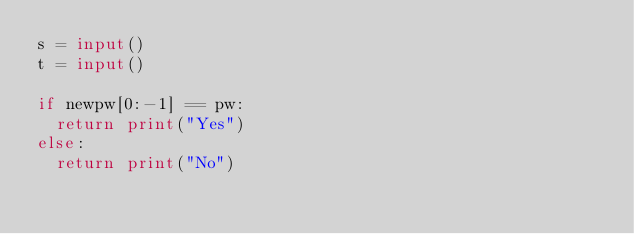<code> <loc_0><loc_0><loc_500><loc_500><_Python_>s = input()
t = input()

if newpw[0:-1] == pw:
  return print("Yes")
else:
  return print("No")

</code> 